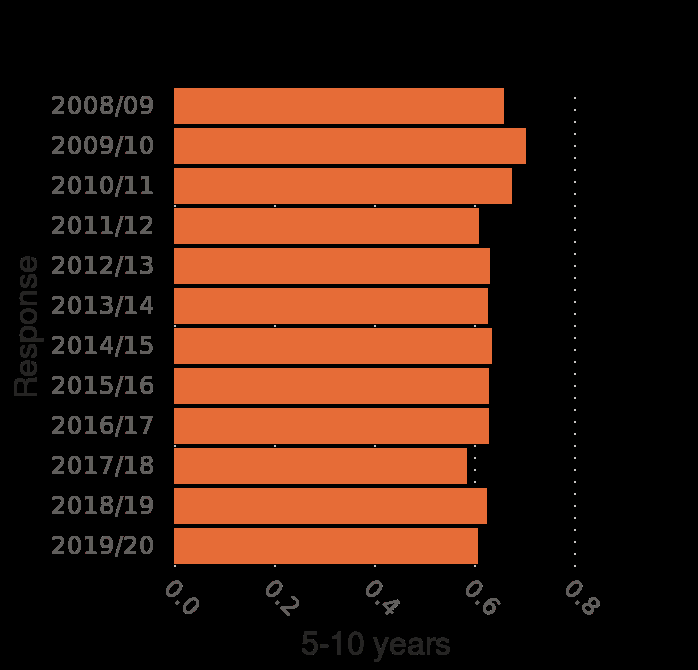<image>
Can we conclude that there has been a decline in the number of children visiting museums over the past ten years?  No, there has not been a decline as the number of children visiting museums has largely remained consistent, only dipping below 0.6 on one occasion. What is plotted on the x-axis and what is its range?  The x-axis plots the age range of 5-10 years on a linear scale from 0.0 to 0.8. What is the time period covered by the graph? The graph covers the time period from 2008/09 to 2019/20. What is the title of the graph?  The title of the graph is "Share of children who visited a museum in England from 2008/09 to 2019/20, by age". Has there been a significant fluctuation in the number of children visiting museums over the past ten years?  No, the number of children visiting museums over the past ten years has remained relatively constant with only a single dip below 0.6. 